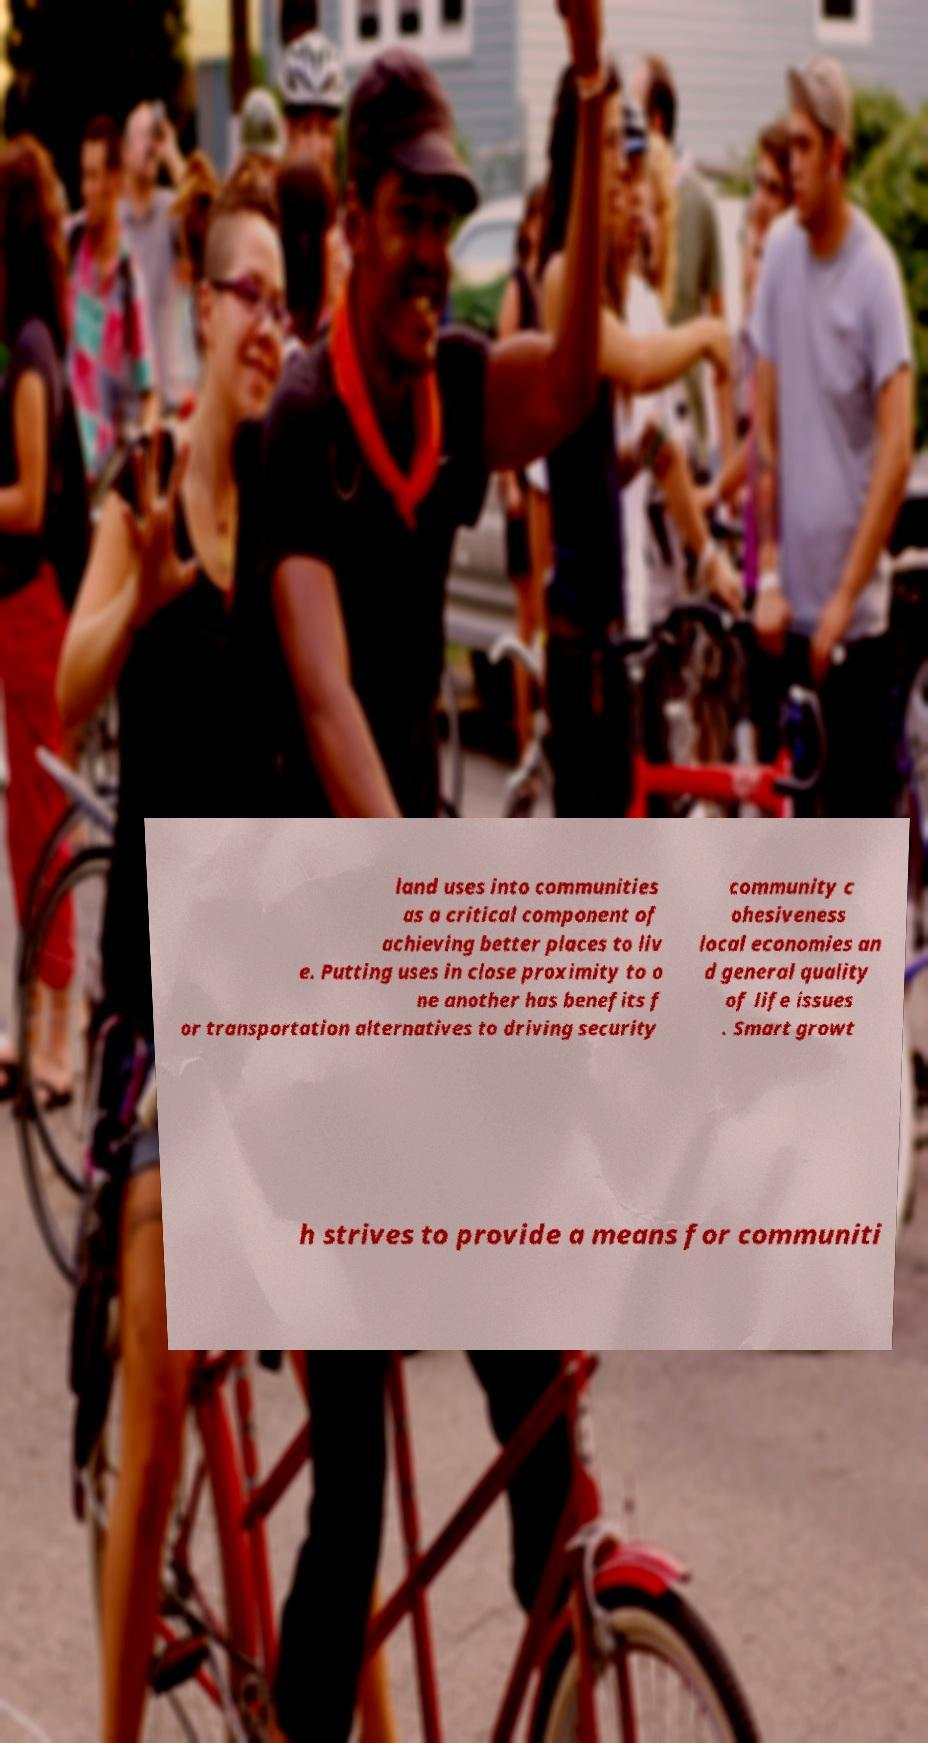Please identify and transcribe the text found in this image. land uses into communities as a critical component of achieving better places to liv e. Putting uses in close proximity to o ne another has benefits f or transportation alternatives to driving security community c ohesiveness local economies an d general quality of life issues . Smart growt h strives to provide a means for communiti 